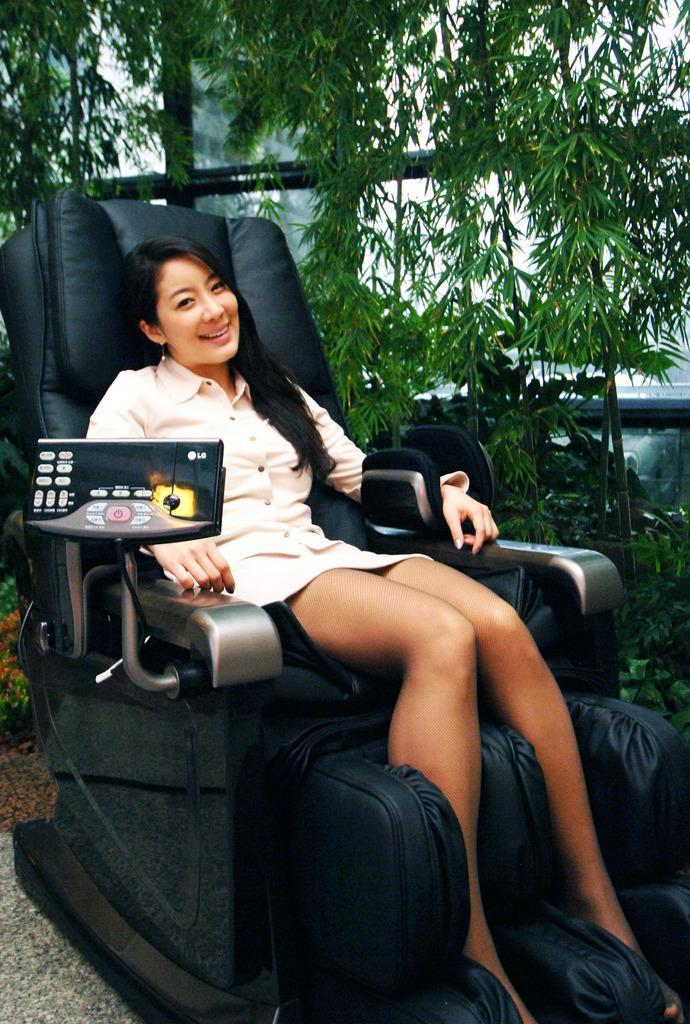Describe this image in one or two sentences. In this image I see a woman, who is sitting on the chair and she is smiling. In the background I see plants. 